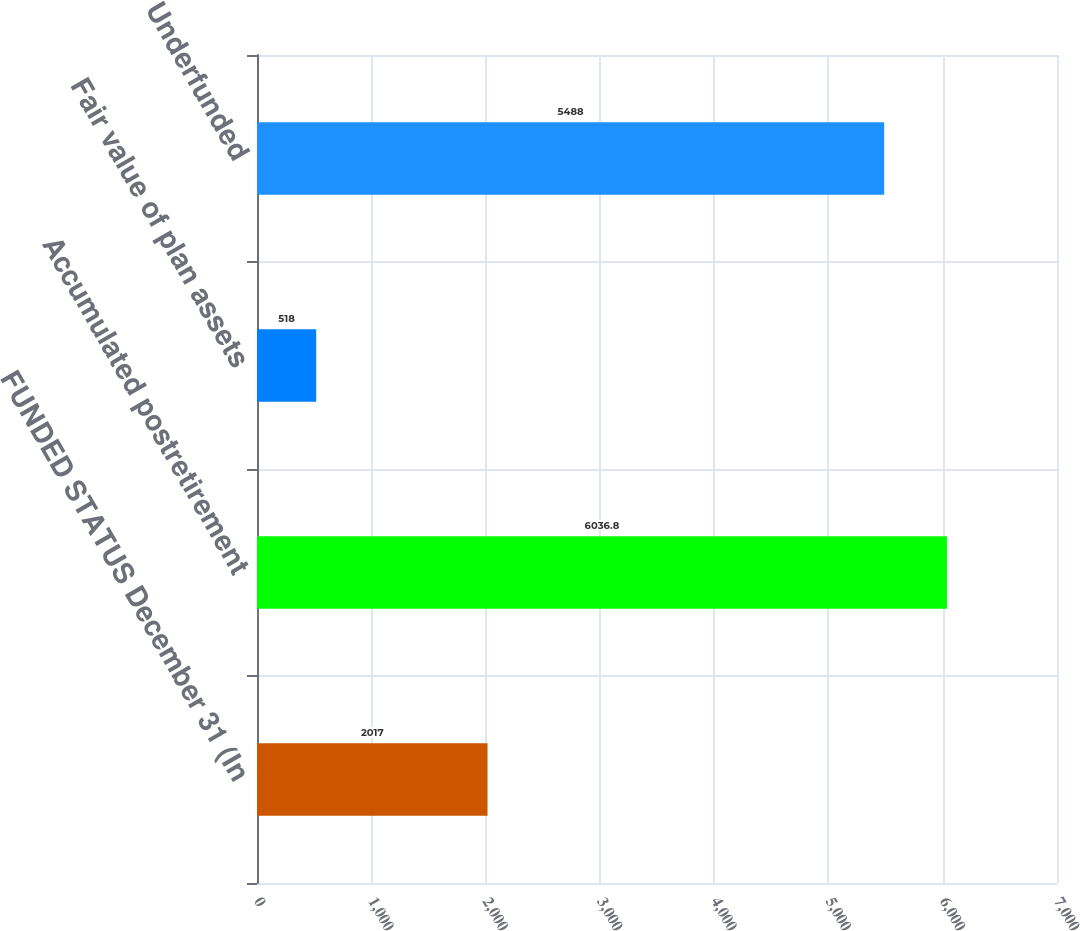Convert chart. <chart><loc_0><loc_0><loc_500><loc_500><bar_chart><fcel>FUNDED STATUS December 31 (In<fcel>Accumulated postretirement<fcel>Fair value of plan assets<fcel>Underfunded<nl><fcel>2017<fcel>6036.8<fcel>518<fcel>5488<nl></chart> 